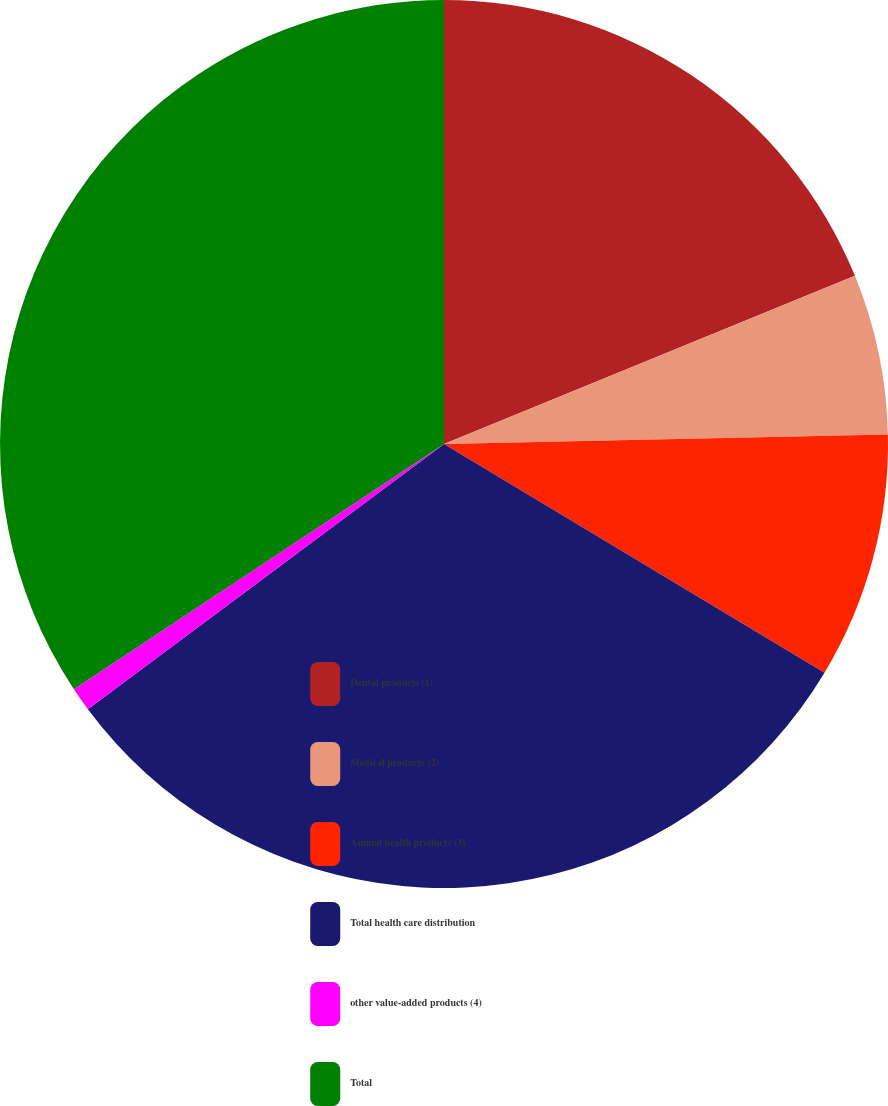<chart> <loc_0><loc_0><loc_500><loc_500><pie_chart><fcel>Dental products (1)<fcel>Medical products (2)<fcel>Animal health products (3)<fcel>Total health care distribution<fcel>other value-added products (4)<fcel>Total<nl><fcel>18.82%<fcel>5.84%<fcel>8.96%<fcel>31.2%<fcel>0.87%<fcel>34.32%<nl></chart> 